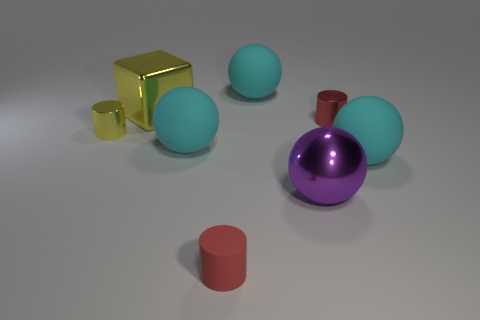Subtract all purple cubes. How many cyan spheres are left? 3 Subtract all large purple spheres. How many spheres are left? 3 Subtract all red balls. Subtract all gray cylinders. How many balls are left? 4 Subtract all cubes. How many objects are left? 7 Add 1 brown matte balls. How many objects exist? 9 Subtract all tiny cyan rubber balls. Subtract all shiny cylinders. How many objects are left? 6 Add 4 large cyan balls. How many large cyan balls are left? 7 Add 5 large red shiny spheres. How many large red shiny spheres exist? 5 Subtract 0 green cubes. How many objects are left? 8 